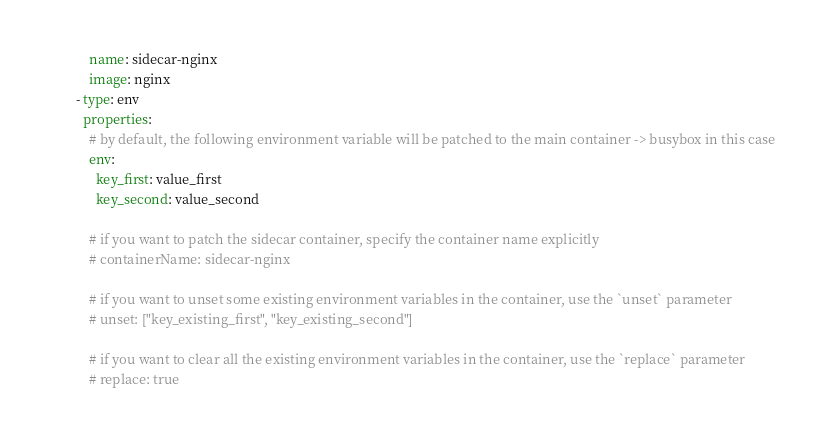<code> <loc_0><loc_0><loc_500><loc_500><_YAML_>            name: sidecar-nginx
            image: nginx
        - type: env
          properties:
            # by default, the following environment variable will be patched to the main container -> busybox in this case
            env:
              key_first: value_first
              key_second: value_second

            # if you want to patch the sidecar container, specify the container name explicitly
            # containerName: sidecar-nginx

            # if you want to unset some existing environment variables in the container, use the `unset` parameter
            # unset: ["key_existing_first", "key_existing_second"]

            # if you want to clear all the existing environment variables in the container, use the `replace` parameter
            # replace: true
</code> 